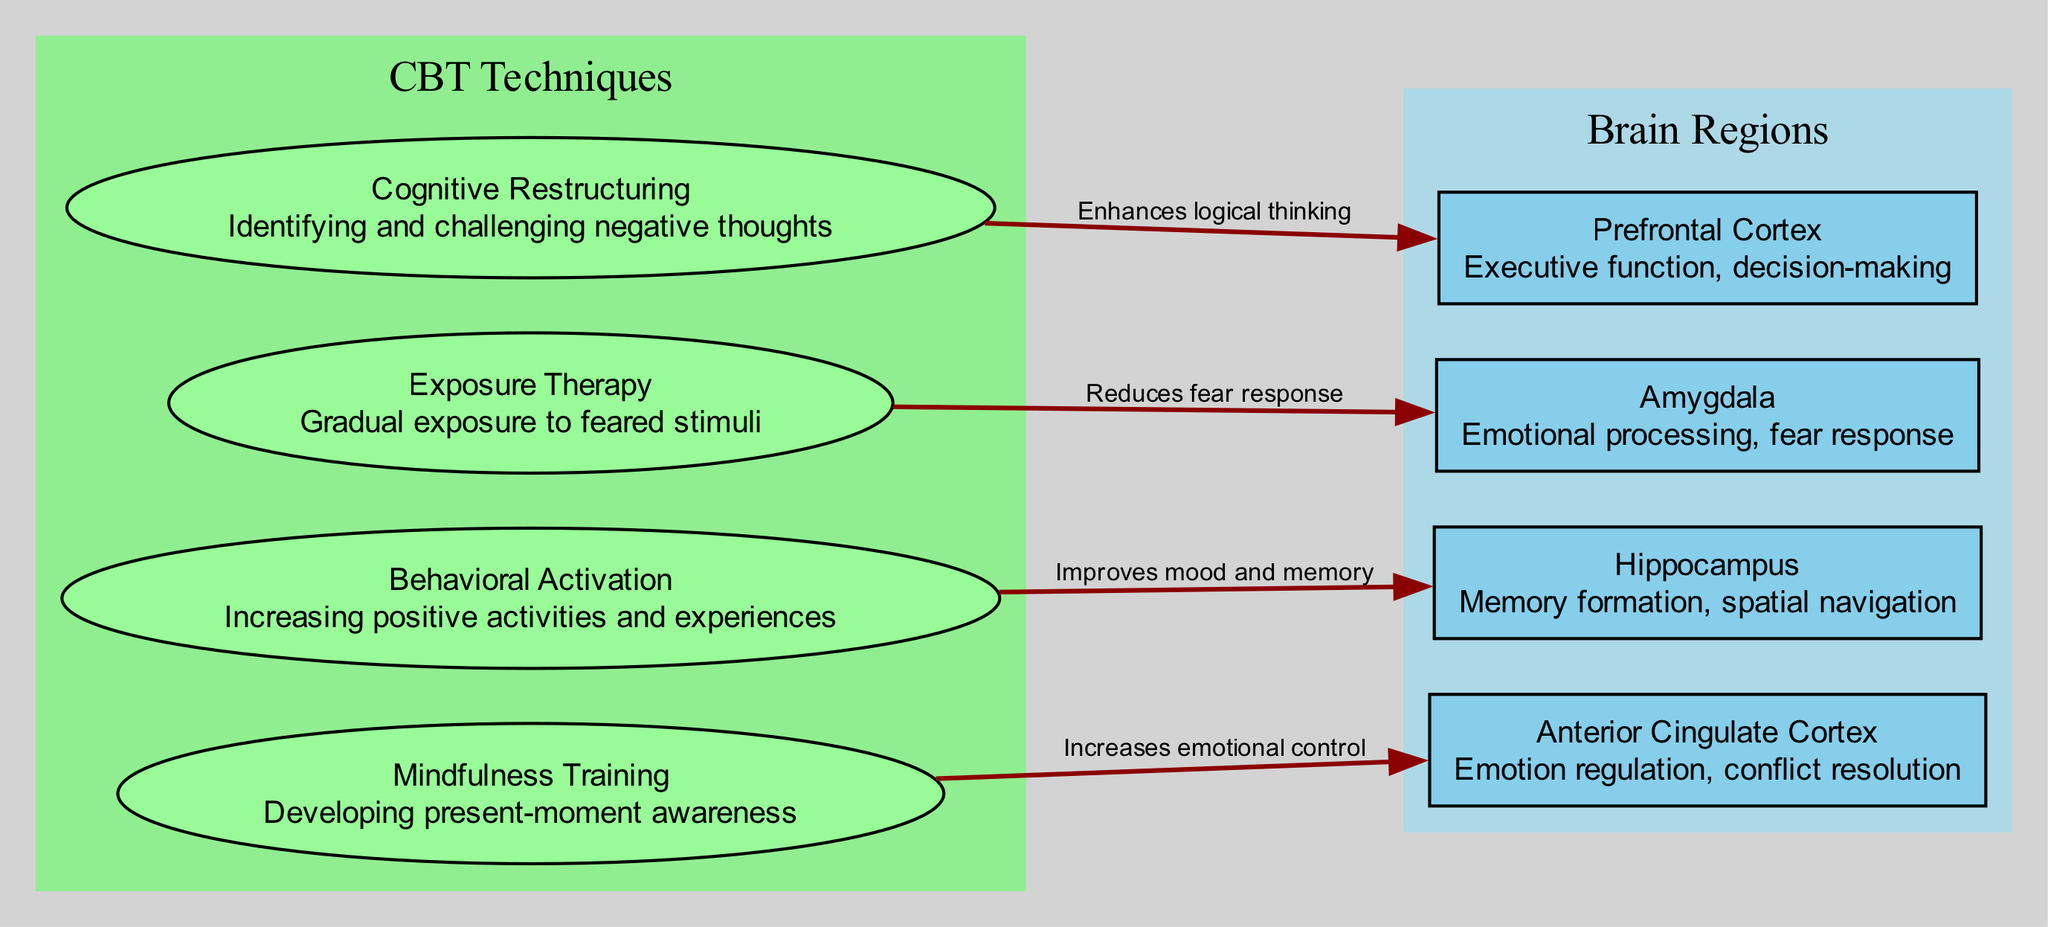What brain region is targeted by Cognitive Restructuring? Cognitive Restructuring is linked to the Prefrontal Cortex in the diagram. This is noted directly on the connections from the CBT technique to the brain region.
Answer: Prefrontal Cortex How many CBT techniques are mapped to brain regions? The diagram includes four CBT techniques that are connected to their corresponding brain regions. Counting each unique technique shows there are four.
Answer: 4 What effect does Exposure Therapy have on the Amygdala? The diagram specifies that Exposure Therapy reduces the fear response associated with the Amygdala, which is indicated by the label on the edge connecting these two nodes.
Answer: Reduces fear response Which techniques target the Hippocampus? The diagram indicates that Behavioral Activation is the only technique targeting the Hippocampus. This is derived from the connection shown in the diagram mapping it specifically to that brain region.
Answer: Behavioral Activation What function is associated with the Anterior Cingulate Cortex? The diagram describes the function of the Anterior Cingulate Cortex as "Emotion regulation, conflict resolution," which is stated directly within the node representing this brain region.
Answer: Emotion regulation, conflict resolution Why is Cognitive Restructuring connected to the Prefrontal Cortex? The diagram highlights that Cognitive Restructuring enhances logical thinking, which relates to the functions of the Prefrontal Cortex involved in executive function and decision-making. Hence, the connection makes sense in the context of cognitive processes.
Answer: Enhances logical thinking What is the main purpose of Mindfulness Training? The diagram states that Mindfulness Training is intended to develop present-moment awareness, which is detailed directly in the description within the node representing the technique.
Answer: Developing present-moment awareness How many edges connect CBT techniques to brain regions? Each of the four CBT techniques in the diagram is connected to a distinct brain region, resulting in a total of four edges in the diagram that reflect these connections.
Answer: 4 What technique is associated with improving mood and memory? The diagram indicates that Behavioral Activation is linked to improving both mood and memory through its connection to the Hippocampus, as noted on the edge in the diagram.
Answer: Behavioral Activation 